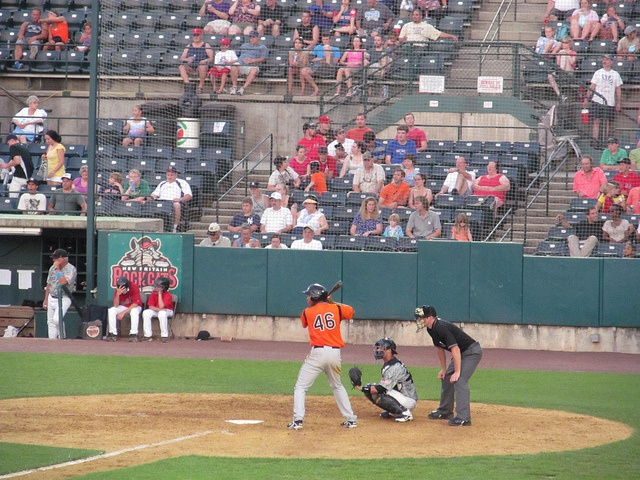Describe the objects in this image and their specific colors. I can see people in black, gray, darkgray, and lightgray tones, people in black, lightgray, red, and darkgray tones, people in black, gray, brown, and salmon tones, people in black, gray, darkgray, and lightgray tones, and people in black, gray, and lightpink tones in this image. 